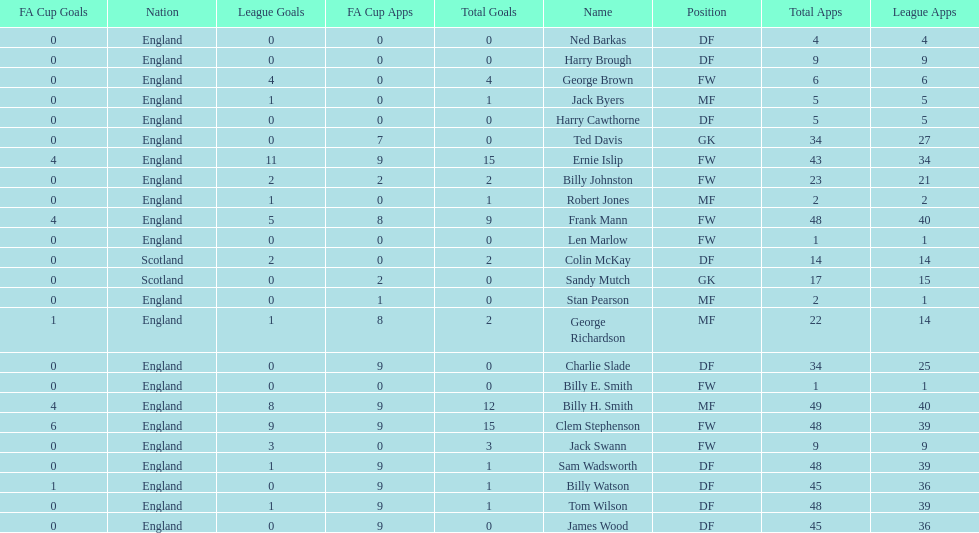What are the number of league apps ted davis has? 27. I'm looking to parse the entire table for insights. Could you assist me with that? {'header': ['FA Cup Goals', 'Nation', 'League Goals', 'FA Cup Apps', 'Total Goals', 'Name', 'Position', 'Total Apps', 'League Apps'], 'rows': [['0', 'England', '0', '0', '0', 'Ned Barkas', 'DF', '4', '4'], ['0', 'England', '0', '0', '0', 'Harry Brough', 'DF', '9', '9'], ['0', 'England', '4', '0', '4', 'George Brown', 'FW', '6', '6'], ['0', 'England', '1', '0', '1', 'Jack Byers', 'MF', '5', '5'], ['0', 'England', '0', '0', '0', 'Harry Cawthorne', 'DF', '5', '5'], ['0', 'England', '0', '7', '0', 'Ted Davis', 'GK', '34', '27'], ['4', 'England', '11', '9', '15', 'Ernie Islip', 'FW', '43', '34'], ['0', 'England', '2', '2', '2', 'Billy Johnston', 'FW', '23', '21'], ['0', 'England', '1', '0', '1', 'Robert Jones', 'MF', '2', '2'], ['4', 'England', '5', '8', '9', 'Frank Mann', 'FW', '48', '40'], ['0', 'England', '0', '0', '0', 'Len Marlow', 'FW', '1', '1'], ['0', 'Scotland', '2', '0', '2', 'Colin McKay', 'DF', '14', '14'], ['0', 'Scotland', '0', '2', '0', 'Sandy Mutch', 'GK', '17', '15'], ['0', 'England', '0', '1', '0', 'Stan Pearson', 'MF', '2', '1'], ['1', 'England', '1', '8', '2', 'George Richardson', 'MF', '22', '14'], ['0', 'England', '0', '9', '0', 'Charlie Slade', 'DF', '34', '25'], ['0', 'England', '0', '0', '0', 'Billy E. Smith', 'FW', '1', '1'], ['4', 'England', '8', '9', '12', 'Billy H. Smith', 'MF', '49', '40'], ['6', 'England', '9', '9', '15', 'Clem Stephenson', 'FW', '48', '39'], ['0', 'England', '3', '0', '3', 'Jack Swann', 'FW', '9', '9'], ['0', 'England', '1', '9', '1', 'Sam Wadsworth', 'DF', '48', '39'], ['1', 'England', '0', '9', '1', 'Billy Watson', 'DF', '45', '36'], ['0', 'England', '1', '9', '1', 'Tom Wilson', 'DF', '48', '39'], ['0', 'England', '0', '9', '0', 'James Wood', 'DF', '45', '36']]} 